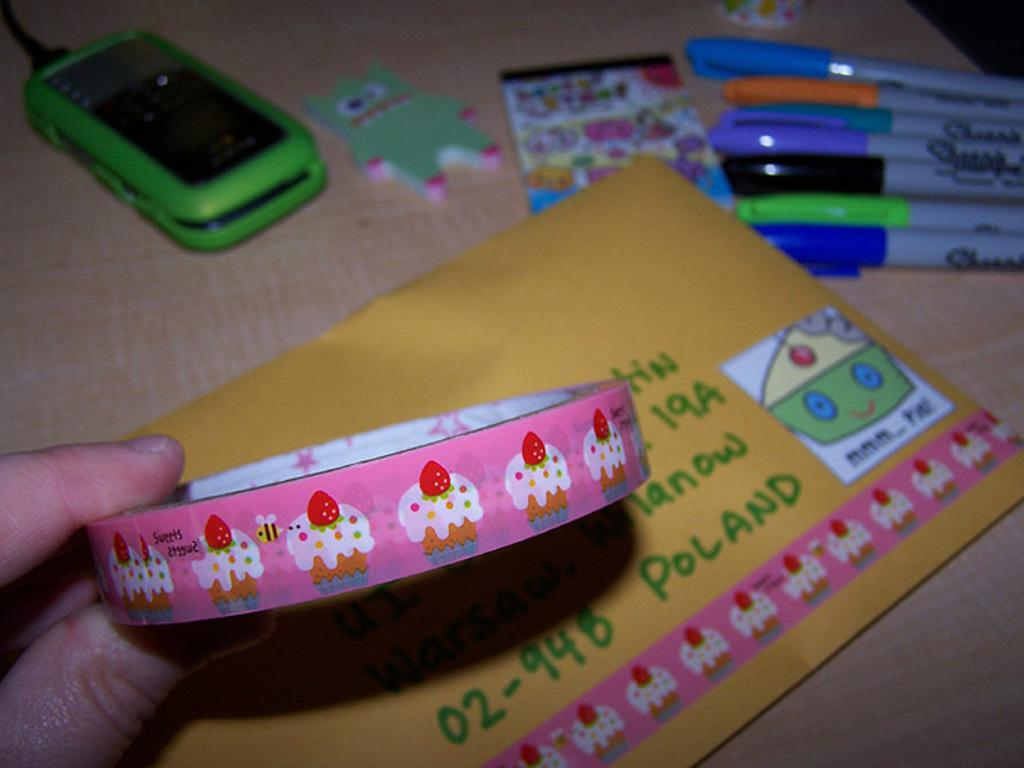<image>
Provide a brief description of the given image. Someone holding cupcake tape over an envelope addressed to somewhere Poland. 